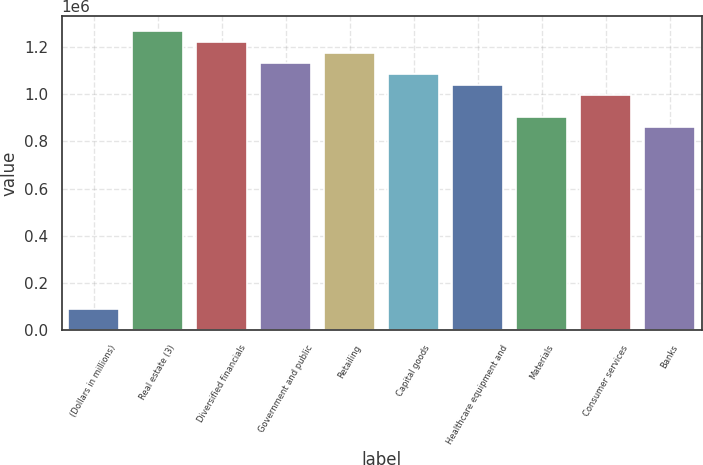Convert chart to OTSL. <chart><loc_0><loc_0><loc_500><loc_500><bar_chart><fcel>(Dollars in millions)<fcel>Real estate (3)<fcel>Diversified financials<fcel>Government and public<fcel>Retailing<fcel>Capital goods<fcel>Healthcare equipment and<fcel>Materials<fcel>Consumer services<fcel>Banks<nl><fcel>91254.4<fcel>1.266e+06<fcel>1.22082e+06<fcel>1.13046e+06<fcel>1.17564e+06<fcel>1.08527e+06<fcel>1.04009e+06<fcel>904543<fcel>994908<fcel>859360<nl></chart> 